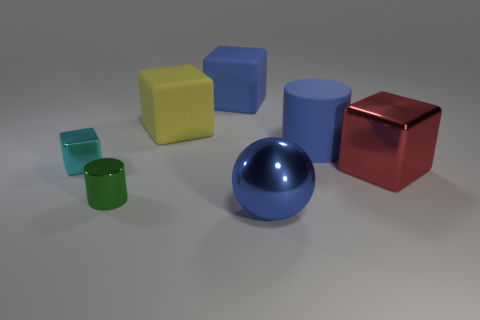Subtract all large red cubes. How many cubes are left? 3 Add 1 blue blocks. How many objects exist? 8 Subtract all green cylinders. How many cylinders are left? 1 Subtract all blocks. How many objects are left? 3 Add 3 cyan cylinders. How many cyan cylinders exist? 3 Subtract 0 green balls. How many objects are left? 7 Subtract 4 blocks. How many blocks are left? 0 Subtract all cyan balls. Subtract all green cylinders. How many balls are left? 1 Subtract all red spheres. How many blue cubes are left? 1 Subtract all red cubes. Subtract all large metal objects. How many objects are left? 4 